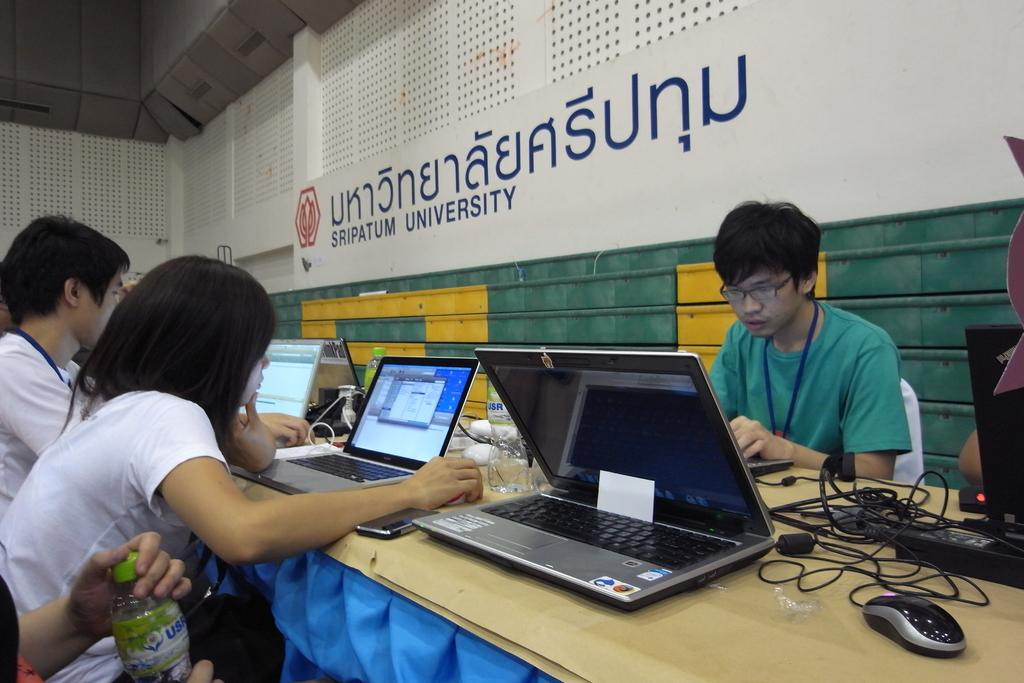Provide a one-sentence caption for the provided image. A group of students working on laptops at Sripatum University. 